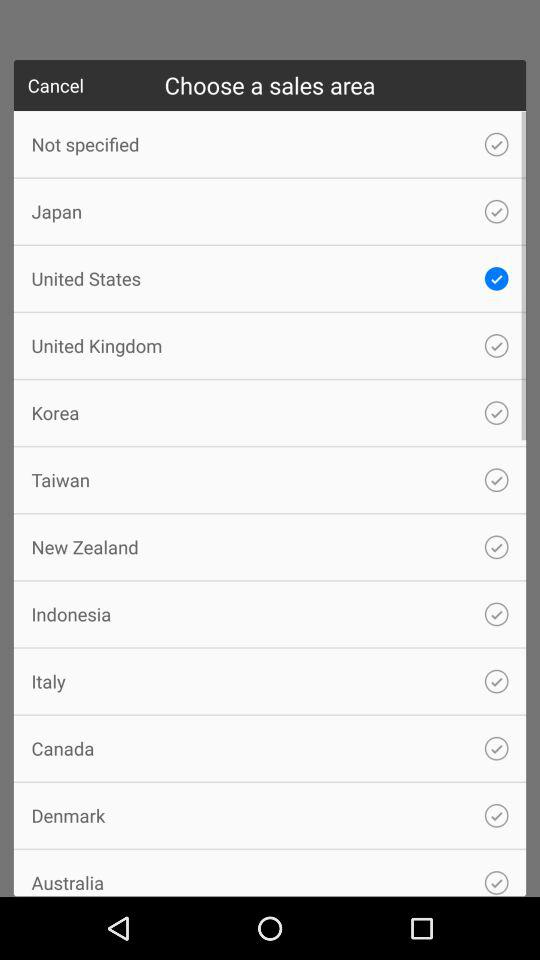When are the sales taking place?
When the provided information is insufficient, respond with <no answer>. <no answer> 